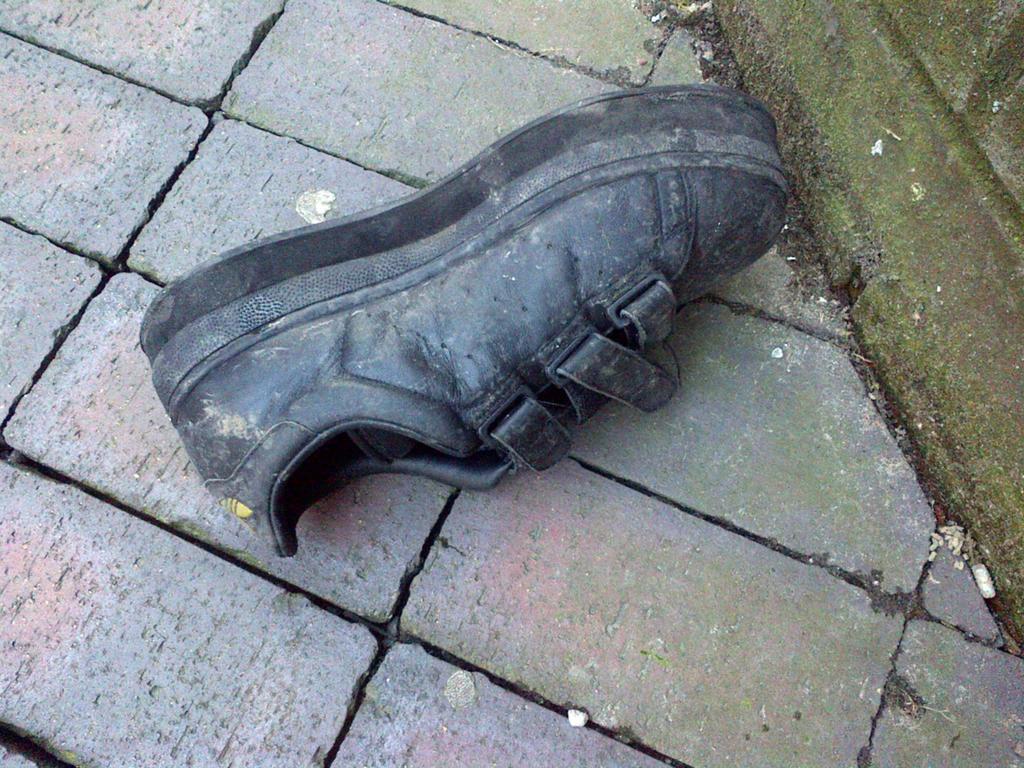Could you give a brief overview of what you see in this image? In the middle of the picture, we see a boot or a shoe in black color. At the bottom, we see the pavement. On the right side, we see a wall which is covered with the algae. 